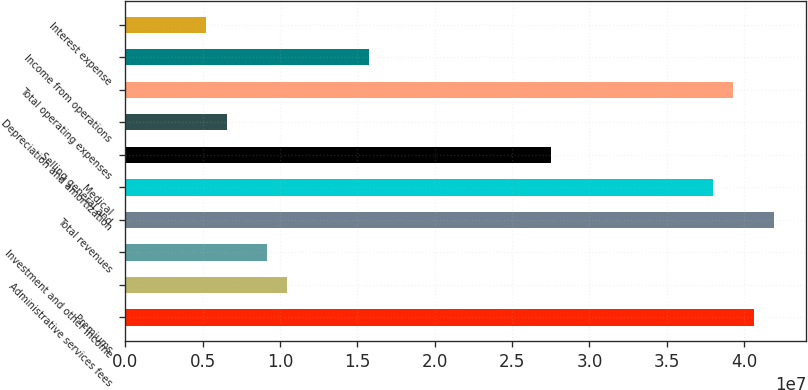Convert chart to OTSL. <chart><loc_0><loc_0><loc_500><loc_500><bar_chart><fcel>Premiums<fcel>Administrative services fees<fcel>Investment and other income<fcel>Total revenues<fcel>Medical<fcel>Selling general and<fcel>Depreciation and amortization<fcel>Total operating expenses<fcel>Income from operations<fcel>Interest expense<nl><fcel>4.06234e+07<fcel>1.04835e+07<fcel>9.17303e+06<fcel>4.19338e+07<fcel>3.80025e+07<fcel>2.75191e+07<fcel>6.55216e+06<fcel>3.9313e+07<fcel>1.57252e+07<fcel>5.24173e+06<nl></chart> 